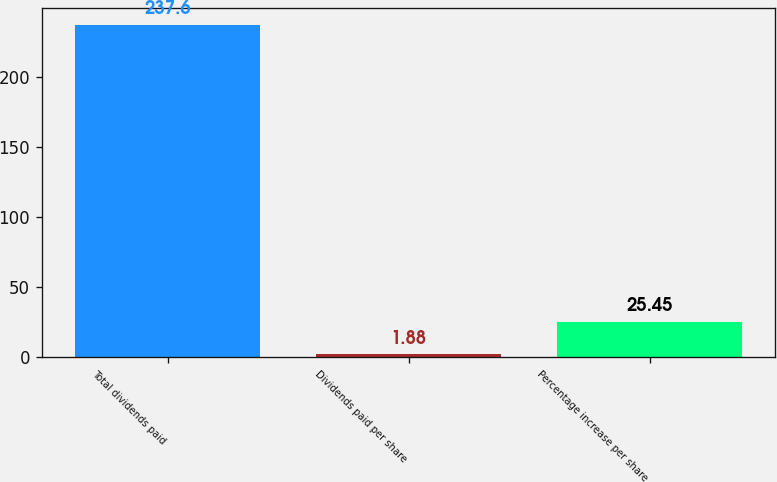Convert chart to OTSL. <chart><loc_0><loc_0><loc_500><loc_500><bar_chart><fcel>Total dividends paid<fcel>Dividends paid per share<fcel>Percentage increase per share<nl><fcel>237.6<fcel>1.88<fcel>25.45<nl></chart> 